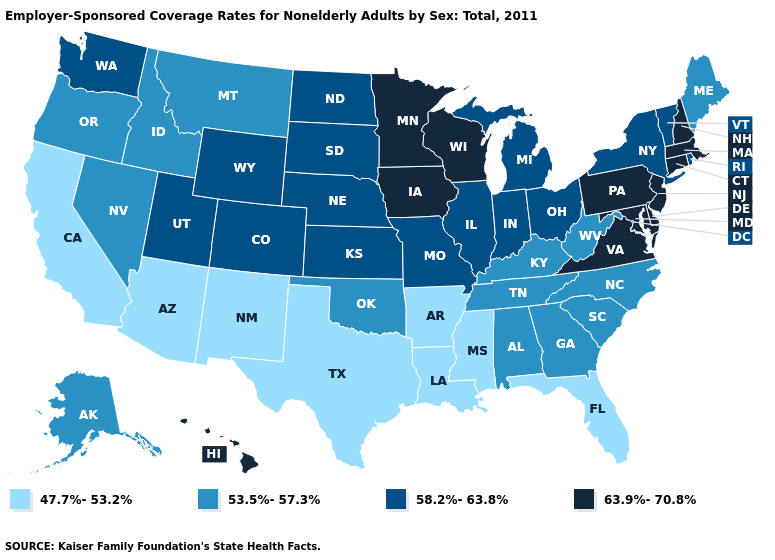Does Michigan have a higher value than Illinois?
Quick response, please. No. Is the legend a continuous bar?
Answer briefly. No. Name the states that have a value in the range 58.2%-63.8%?
Be succinct. Colorado, Illinois, Indiana, Kansas, Michigan, Missouri, Nebraska, New York, North Dakota, Ohio, Rhode Island, South Dakota, Utah, Vermont, Washington, Wyoming. Name the states that have a value in the range 63.9%-70.8%?
Quick response, please. Connecticut, Delaware, Hawaii, Iowa, Maryland, Massachusetts, Minnesota, New Hampshire, New Jersey, Pennsylvania, Virginia, Wisconsin. Does Maine have the lowest value in the Northeast?
Keep it brief. Yes. What is the value of Montana?
Answer briefly. 53.5%-57.3%. Which states have the highest value in the USA?
Short answer required. Connecticut, Delaware, Hawaii, Iowa, Maryland, Massachusetts, Minnesota, New Hampshire, New Jersey, Pennsylvania, Virginia, Wisconsin. Does the first symbol in the legend represent the smallest category?
Write a very short answer. Yes. Name the states that have a value in the range 53.5%-57.3%?
Short answer required. Alabama, Alaska, Georgia, Idaho, Kentucky, Maine, Montana, Nevada, North Carolina, Oklahoma, Oregon, South Carolina, Tennessee, West Virginia. What is the value of Ohio?
Be succinct. 58.2%-63.8%. Name the states that have a value in the range 47.7%-53.2%?
Concise answer only. Arizona, Arkansas, California, Florida, Louisiana, Mississippi, New Mexico, Texas. What is the highest value in the USA?
Concise answer only. 63.9%-70.8%. 